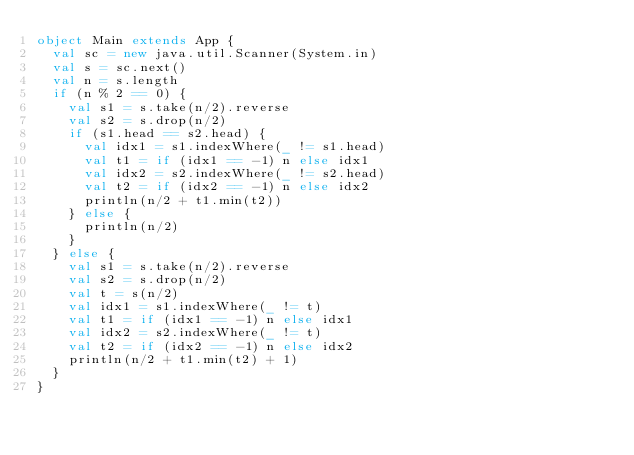<code> <loc_0><loc_0><loc_500><loc_500><_Scala_>object Main extends App {
  val sc = new java.util.Scanner(System.in)
  val s = sc.next()
  val n = s.length
  if (n % 2 == 0) {
    val s1 = s.take(n/2).reverse
    val s2 = s.drop(n/2)
    if (s1.head == s2.head) {
      val idx1 = s1.indexWhere(_ != s1.head)
      val t1 = if (idx1 == -1) n else idx1
      val idx2 = s2.indexWhere(_ != s2.head)
      val t2 = if (idx2 == -1) n else idx2
      println(n/2 + t1.min(t2))
    } else {
      println(n/2)
    }
  } else {
    val s1 = s.take(n/2).reverse
    val s2 = s.drop(n/2)
    val t = s(n/2)
    val idx1 = s1.indexWhere(_ != t)
    val t1 = if (idx1 == -1) n else idx1
    val idx2 = s2.indexWhere(_ != t)
    val t2 = if (idx2 == -1) n else idx2
    println(n/2 + t1.min(t2) + 1)
  }
}
</code> 